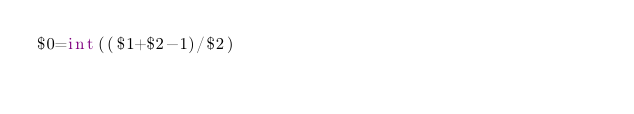Convert code to text. <code><loc_0><loc_0><loc_500><loc_500><_Awk_>$0=int(($1+$2-1)/$2)</code> 